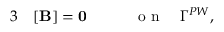Convert formula to latex. <formula><loc_0><loc_0><loc_500><loc_500>\begin{array} { r l r } { 3 } & [ { \mathbf B } ] = 0 \quad } & { o n \quad \Gamma ^ { P W } , } \end{array}</formula> 